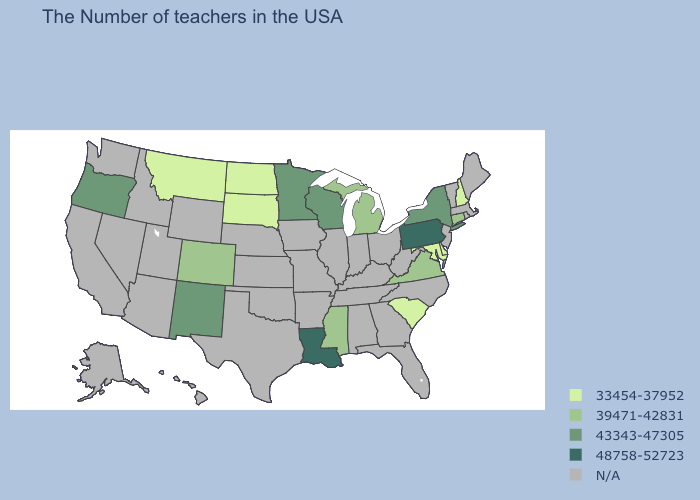Name the states that have a value in the range N/A?
Write a very short answer. Maine, Massachusetts, Rhode Island, Vermont, New Jersey, North Carolina, West Virginia, Ohio, Florida, Georgia, Kentucky, Indiana, Alabama, Tennessee, Illinois, Missouri, Arkansas, Iowa, Kansas, Nebraska, Oklahoma, Texas, Wyoming, Utah, Arizona, Idaho, Nevada, California, Washington, Alaska, Hawaii. Which states have the highest value in the USA?
Short answer required. Pennsylvania, Louisiana. Name the states that have a value in the range 33454-37952?
Concise answer only. New Hampshire, Delaware, Maryland, South Carolina, South Dakota, North Dakota, Montana. What is the lowest value in states that border Tennessee?
Answer briefly. 39471-42831. Name the states that have a value in the range 48758-52723?
Short answer required. Pennsylvania, Louisiana. Among the states that border Minnesota , which have the highest value?
Give a very brief answer. Wisconsin. Does the first symbol in the legend represent the smallest category?
Keep it brief. Yes. Does Wisconsin have the highest value in the MidWest?
Short answer required. Yes. Does the map have missing data?
Write a very short answer. Yes. What is the lowest value in the USA?
Answer briefly. 33454-37952. Name the states that have a value in the range N/A?
Give a very brief answer. Maine, Massachusetts, Rhode Island, Vermont, New Jersey, North Carolina, West Virginia, Ohio, Florida, Georgia, Kentucky, Indiana, Alabama, Tennessee, Illinois, Missouri, Arkansas, Iowa, Kansas, Nebraska, Oklahoma, Texas, Wyoming, Utah, Arizona, Idaho, Nevada, California, Washington, Alaska, Hawaii. Name the states that have a value in the range 43343-47305?
Quick response, please. New York, Wisconsin, Minnesota, New Mexico, Oregon. Name the states that have a value in the range N/A?
Give a very brief answer. Maine, Massachusetts, Rhode Island, Vermont, New Jersey, North Carolina, West Virginia, Ohio, Florida, Georgia, Kentucky, Indiana, Alabama, Tennessee, Illinois, Missouri, Arkansas, Iowa, Kansas, Nebraska, Oklahoma, Texas, Wyoming, Utah, Arizona, Idaho, Nevada, California, Washington, Alaska, Hawaii. 